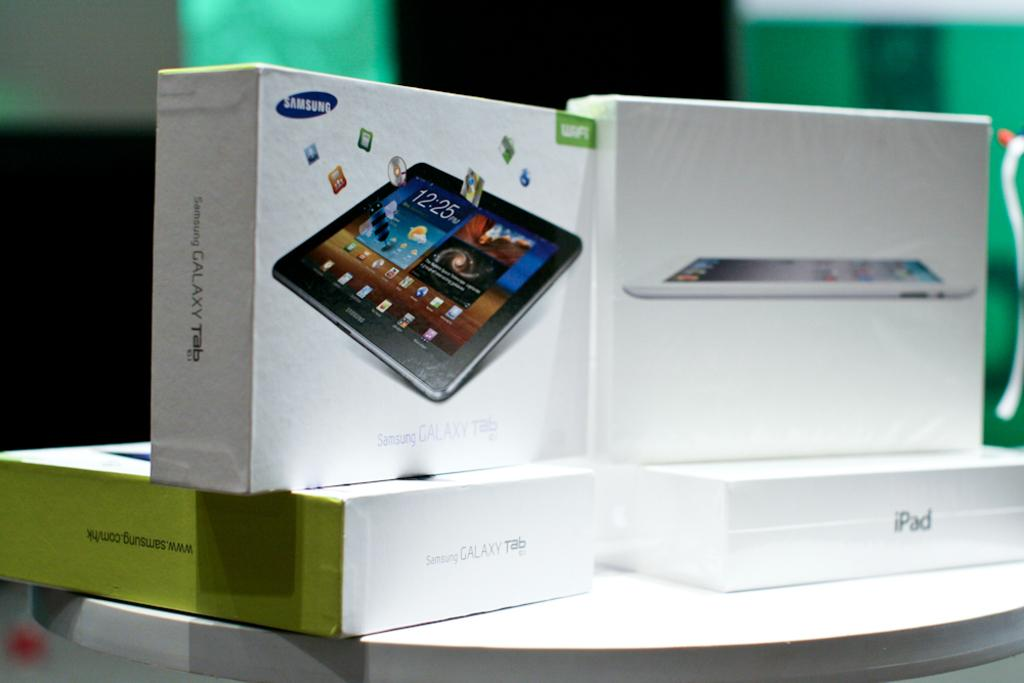How many boxes are visible in the image? There are four white color boxes in the image. What is the color of the table on which the boxes are placed? The boxes are placed on a white color table. What do the boxes resemble in terms of their shape and purpose? The boxes resemble tablet boxes. Can you describe the background of the image? The background of the image is blurred. What type of straw is growing out of the boxes in the image? There is no straw growing out of the boxes in the image. What kind of plants can be seen in the background of the image? There are no plants visible in the image, as the background is blurred. 